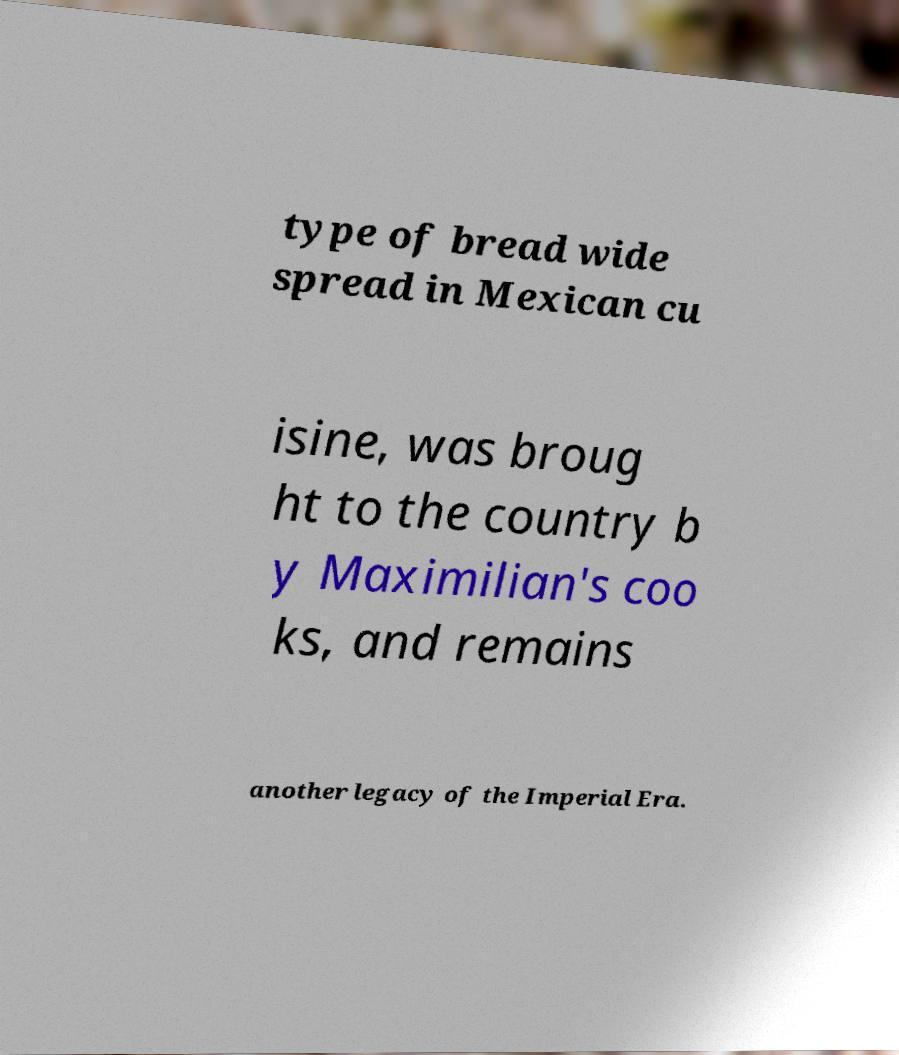Please identify and transcribe the text found in this image. type of bread wide spread in Mexican cu isine, was broug ht to the country b y Maximilian's coo ks, and remains another legacy of the Imperial Era. 